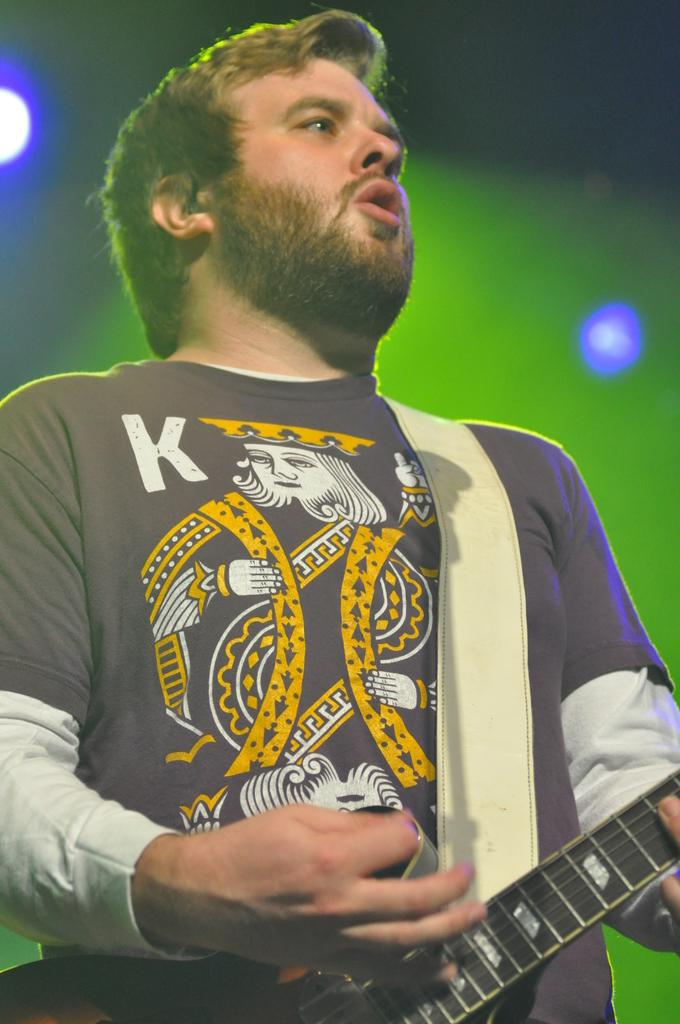Who or what is the main subject of the image? There is a person in the image. What is the person wearing? The person is wearing a black T-shirt. What is the person holding in the image? The person is holding a guitar. What can be seen in the background of the image? There are lights visible in the background of the image. What word is written on the person's apparel in the image? There is no word written on the person's apparel in the image; they are wearing a plain black T-shirt. 